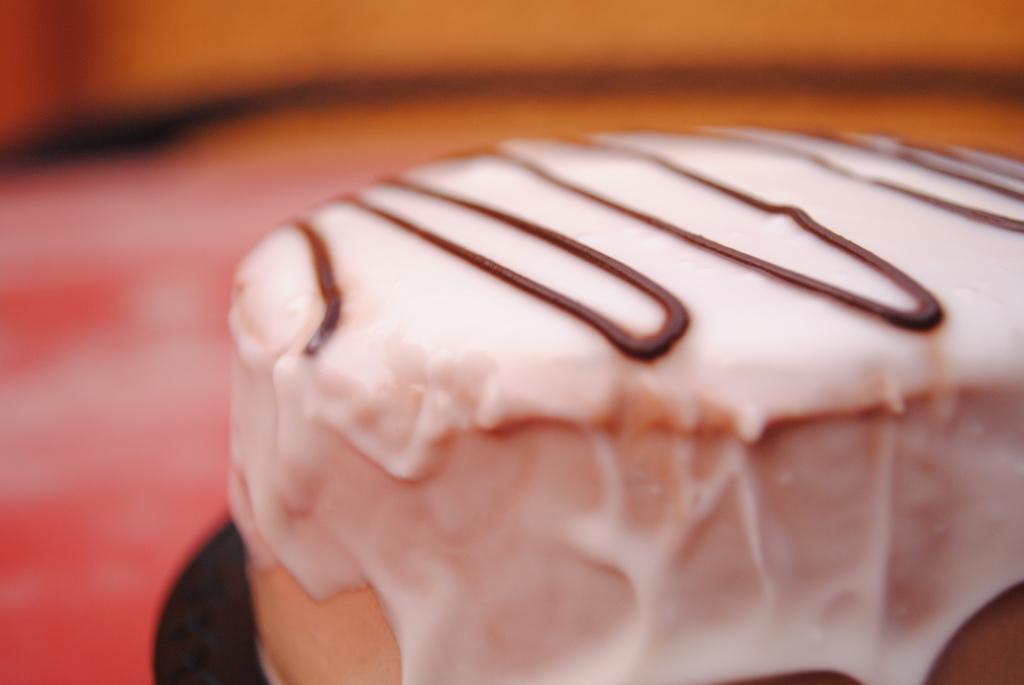Please provide a concise description of this image. In this image, I can see a piece of cake with cream. The background looks blurry. 